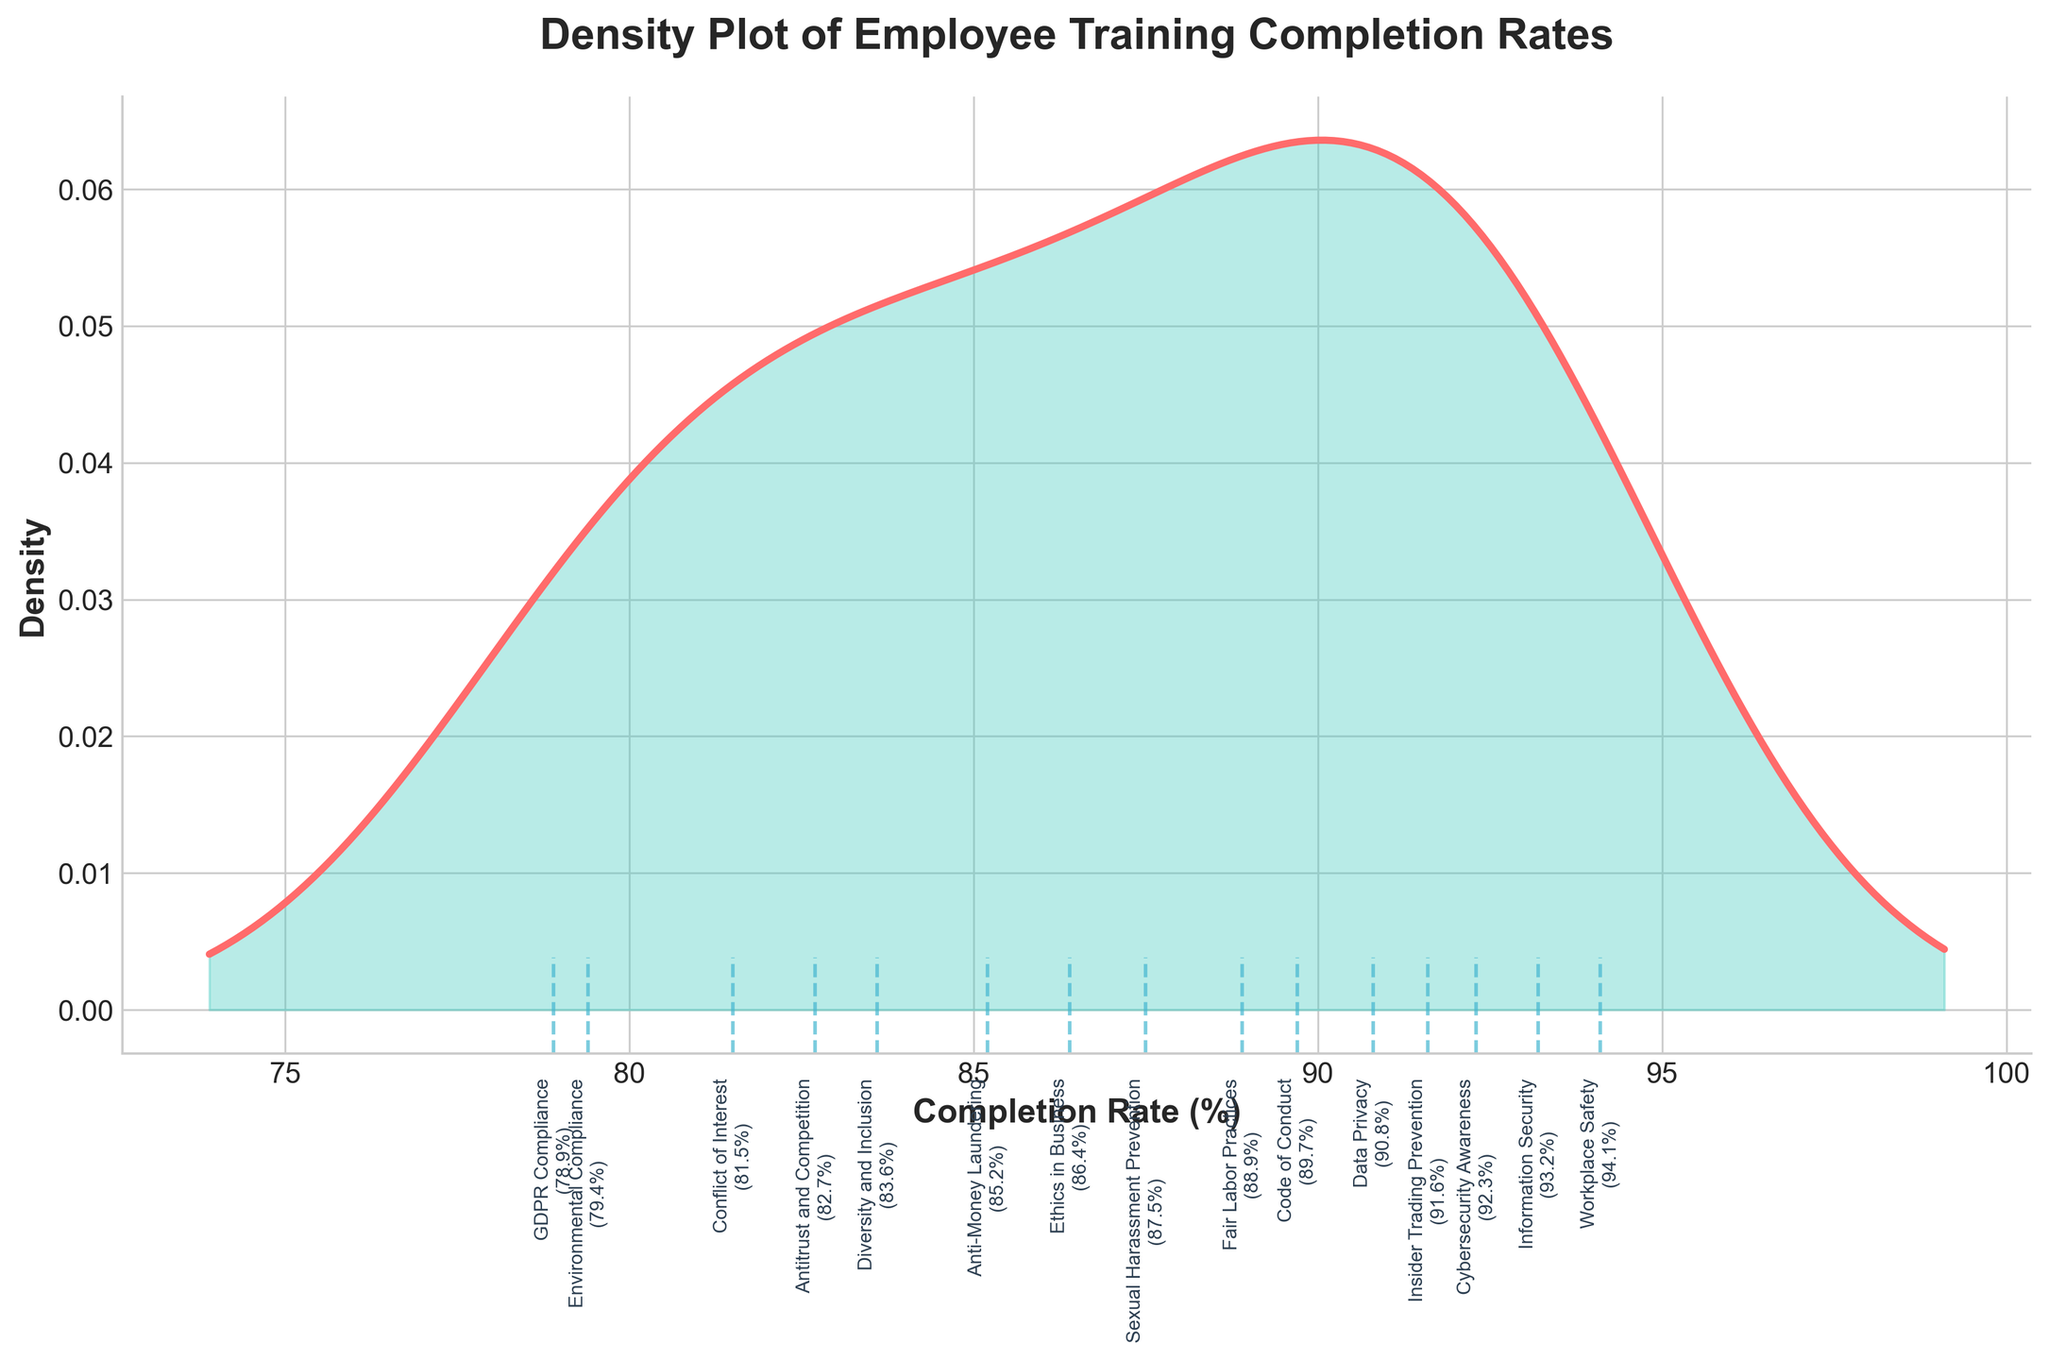What is the title of the figure? The title is prominently displayed at the top of the figure.
Answer: Density Plot of Employee Training Completion Rates What are the units used for the x-axis? The labels on the x-axis show percentages, indicating that the units are in %.
Answer: % What is the density value of the peak in the plot? Look for the highest point on the density curve and note its y-axis value.
Answer: Around 0.035 What module has the highest completion rate? Identify the vertical line on the far right of the x-axis, indicating the highest completion rate.
Answer: Workplace Safety What module has the lowest completion rate? Identify the vertical line on the far left of the x-axis, indicating the lowest completion rate.
Answer: GDPR Compliance How many modules have completion rates below 85%? Count the number of vertical lines with x-values below 85 on the plot.
Answer: 6 modules Are there more modules with completion rates above 90% or below 80%? Compare the number of vertical lines above 90 and below 80 on the x-axis.
Answer: Above 90% What is the range of completion rates for the modules? Subtract the smallest completion rate value from the largest completion rate value visible along the x-axis.
Answer: 94.1% - 78.9% = 15.2% Which module completion rate is closest to the mean completion rate? Calculate the mean of all completion rates and find the vertical line closest in value to this mean on the x-axis.
Answer: Ethics in Business 